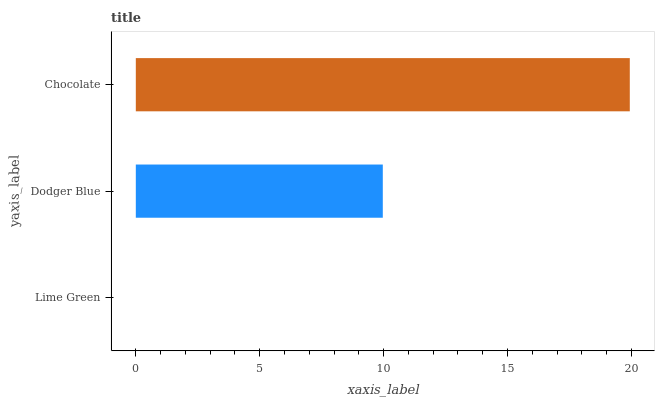Is Lime Green the minimum?
Answer yes or no. Yes. Is Chocolate the maximum?
Answer yes or no. Yes. Is Dodger Blue the minimum?
Answer yes or no. No. Is Dodger Blue the maximum?
Answer yes or no. No. Is Dodger Blue greater than Lime Green?
Answer yes or no. Yes. Is Lime Green less than Dodger Blue?
Answer yes or no. Yes. Is Lime Green greater than Dodger Blue?
Answer yes or no. No. Is Dodger Blue less than Lime Green?
Answer yes or no. No. Is Dodger Blue the high median?
Answer yes or no. Yes. Is Dodger Blue the low median?
Answer yes or no. Yes. Is Lime Green the high median?
Answer yes or no. No. Is Chocolate the low median?
Answer yes or no. No. 